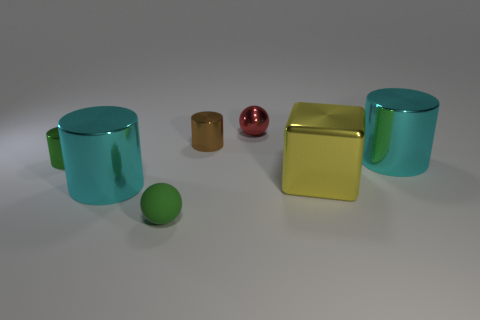Add 2 large matte blocks. How many objects exist? 9 Subtract all blocks. How many objects are left? 6 Add 5 brown metal objects. How many brown metal objects are left? 6 Add 7 small brown things. How many small brown things exist? 8 Subtract 0 yellow spheres. How many objects are left? 7 Subtract all tiny yellow metal cubes. Subtract all tiny metallic cylinders. How many objects are left? 5 